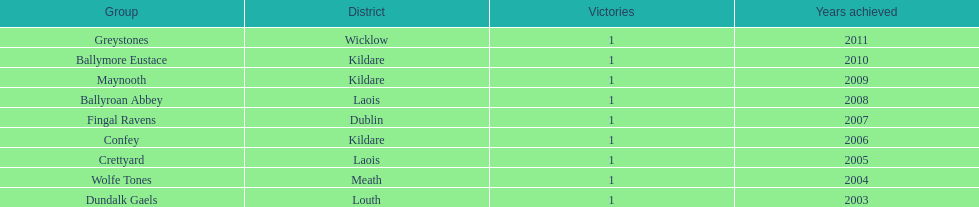In which years did each team achieve victory? 2011, 2010, 2009, 2008, 2007, 2006, 2005, 2004, 2003. 